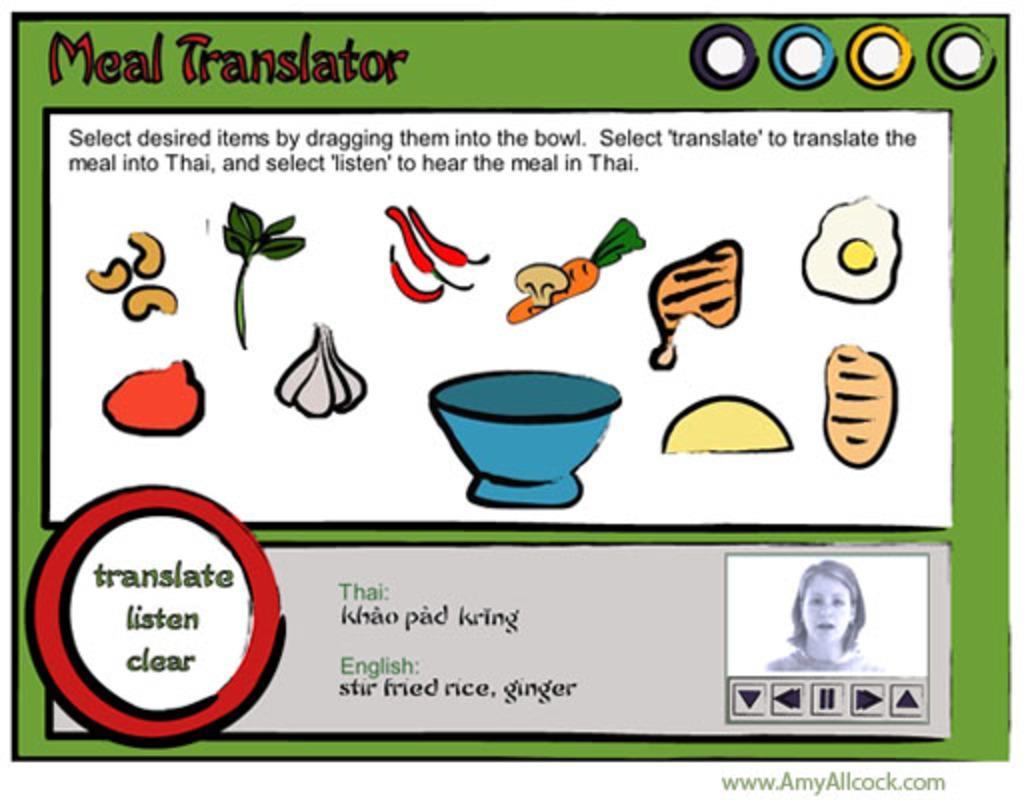Can you describe this image briefly? This is the edited graphic image with some text written on it. 